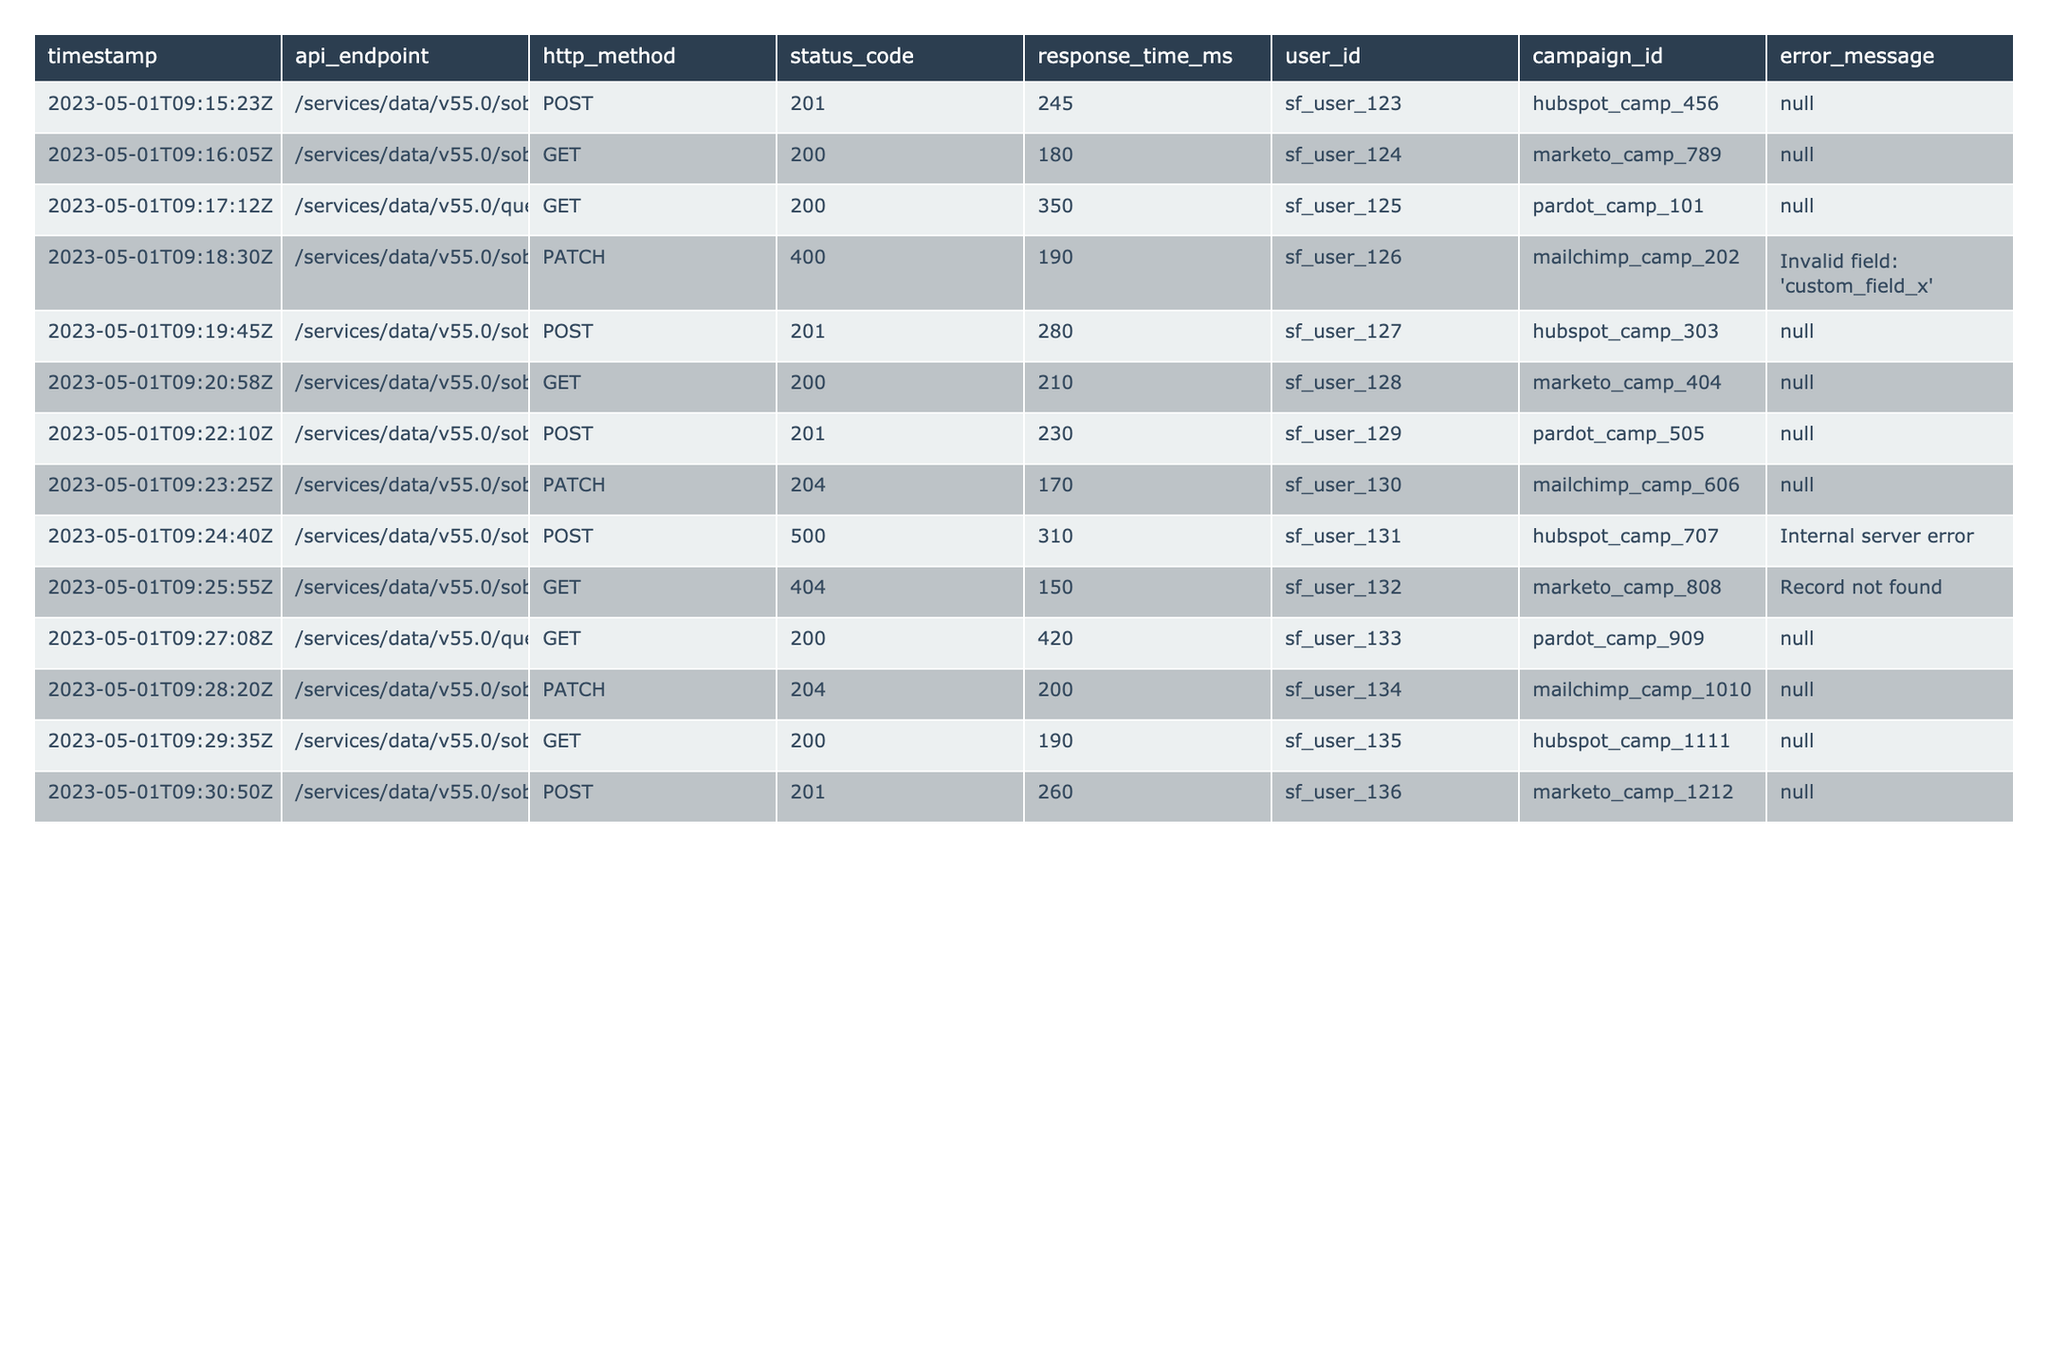What is the HTTP method used most frequently in the logs? Looking at the "http_method" column, I count the occurrences of each method: POST appears 5 times, GET appears 6 times, and PATCH appears 3 times. Therefore, GET is used most frequently with 6 occurrences.
Answer: GET What was the status code for the API call to the Lead endpoint at timestamp 2023-05-01T09:24:40Z? Referring to the "timestamp" column, the entry for the Lead API call at that specific time shows a status code of 500, indicating an internal server error.
Answer: 500 How many total API calls returned a successful status code (2xx)? I review all status codes listed and count the codes starting with '2': there are 7 instances of 2xx status codes.
Answer: 7 Is there any API call that resulted in an error message? Looking at the "error_message" column, there are two entries with error messages: "Internal server error" and "Record not found." Therefore, the answer is yes.
Answer: Yes What is the average response time for all API calls? I first sum the "response_time_ms" values: 245 + 180 + 350 + 190 + 280 + 210 + 230 + 170 + 310 + 150 + 420 + 200 + 190 + 260 = 3250 ms. With 14 total calls, I calculate the average as 3250 / 14 ≈ 232.14 ms.
Answer: 232.14 ms Was the PATCH method used for any API calls that resulted in a successful response? Reviewing the "http_method" and "status_code" columns, I find that the PATCH method was used 3 times, and one of these resulted in a status code of 204, which indicates success. Therefore, the answer is yes.
Answer: Yes Which API endpoint was accessed by user_id "sf_user_130" and what was the response time? Looking up "user_id" for "sf_user_130," I see that the accessed endpoint was "/services/data/v55.0/sobjects/Event" with a response time of 170 ms.
Answer: /services/data/v55.0/sobjects/Event, 170 ms What is the difference in response time between the fastest and slowest API calls? I identify the fastest response time is 150 ms (Contact GET) and the slowest is 420 ms (query GET). The difference is 420 - 150 = 270 ms.
Answer: 270 ms How many unique user IDs made API calls? I examine the "user_id" column and find 14 distinct user IDs without duplication.
Answer: 14 Did any API call to the Account endpoint encounter an error? Two calls to the Account endpoint were made. One resulted in a successful 200 status code while the other with a 400 status code recorded an error message about 'custom_field_x'. So at least one encountered an error.
Answer: Yes What percentage of total API calls resulted in a status code of 404? There is 1 API call with a status code of 404 out of 14 total calls, yielding a percentage of (1/14) * 100 ≈ 7.14%.
Answer: 7.14% 